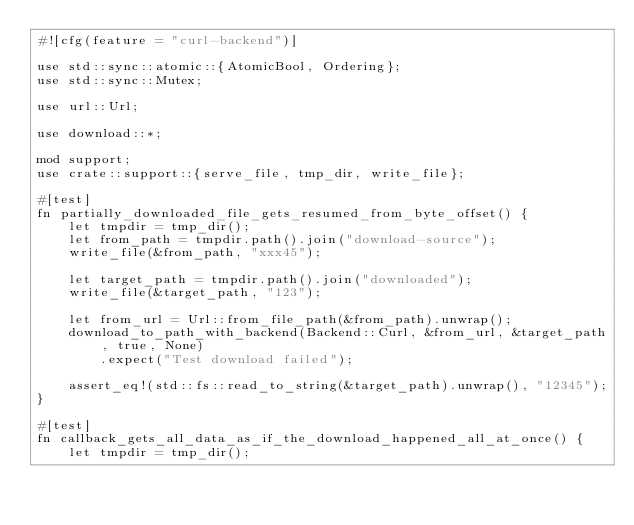Convert code to text. <code><loc_0><loc_0><loc_500><loc_500><_Rust_>#![cfg(feature = "curl-backend")]

use std::sync::atomic::{AtomicBool, Ordering};
use std::sync::Mutex;

use url::Url;

use download::*;

mod support;
use crate::support::{serve_file, tmp_dir, write_file};

#[test]
fn partially_downloaded_file_gets_resumed_from_byte_offset() {
    let tmpdir = tmp_dir();
    let from_path = tmpdir.path().join("download-source");
    write_file(&from_path, "xxx45");

    let target_path = tmpdir.path().join("downloaded");
    write_file(&target_path, "123");

    let from_url = Url::from_file_path(&from_path).unwrap();
    download_to_path_with_backend(Backend::Curl, &from_url, &target_path, true, None)
        .expect("Test download failed");

    assert_eq!(std::fs::read_to_string(&target_path).unwrap(), "12345");
}

#[test]
fn callback_gets_all_data_as_if_the_download_happened_all_at_once() {
    let tmpdir = tmp_dir();</code> 